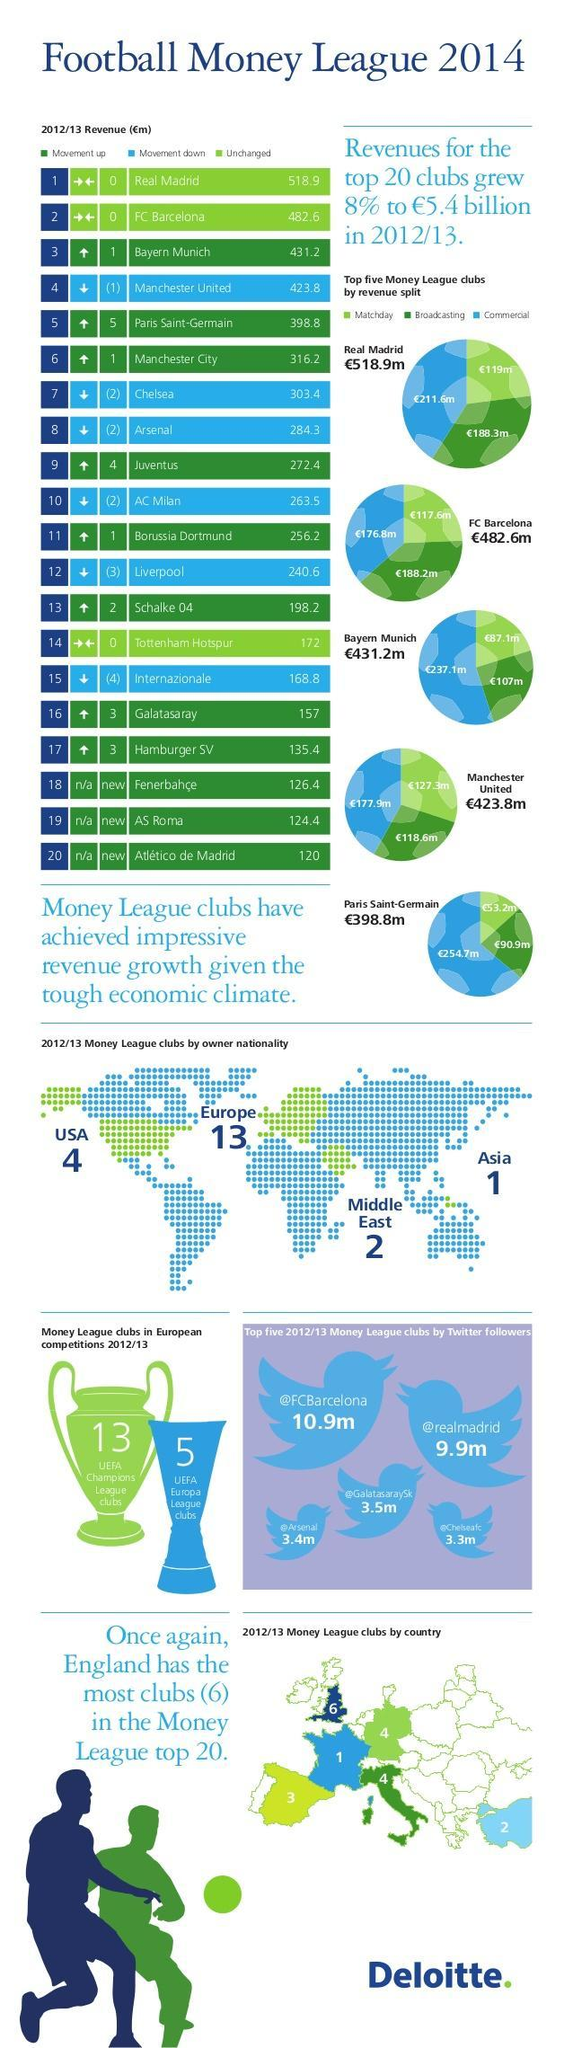How many UEFA champions league clubs are there?
Answer the question with a short phrase. 13 Which three league clubs had a revenue between €300m and €400m ? Chelsia, Manchester City, Paris Saint-Germain How many pie charts are shown here? 5 How many Twitter followers does FC Barcelona have? 10.9m What does the two arrows facing each other (→←) indicate? Unchanged How has the position of Manchester City changed - moved down, moved up or unchanged? Moved up Out of the total revenue for Real Madrid, how much was for broadcasting (€m)? 188.3 By how many positions has Arsenal moved down? 2 What does the up arrow indicate? Movement up In Europe, which country has the highest number of clubs in the Money league Top 20? England Which are the three Money league clubs which have maintained the same position (unchanged)? Real Madrid, FC Barcelona, Tottenham Hotspur By how many positions has Bayern Munich moved up? 1 Which league club has moved down by four positions? Internazionale How many UEFA league clubs are there in total? 18 What colour is used to represent 'movement down' - green, white or blue? Blue What is the revenue share for 'commercial', for FC Barcelona (€m)? 176.8 Which league clubs have moved up by 4 positions? Juventus How many 'new' league clubs are there in the top 20 ? 3 How many 'more' Twitter followers does Real Madrid have than Chelsea(in millions)? 6.6 How many UEFA Europa league clubs are there? 5 Who owns the most Money League clubs -  Middle East, USA or Asia? USA Who has a higher revenue, Manchester United or Manchester City? Manchester United How much was the revenue of FC Barcelona lesser than that for Real Madrid (in million pounds)? 36.3 Which club has the second highest number of Twitter followers? Real Madrid What does the down arrow indicate? Movement down How many Money League clubs are owned by USA? 4 